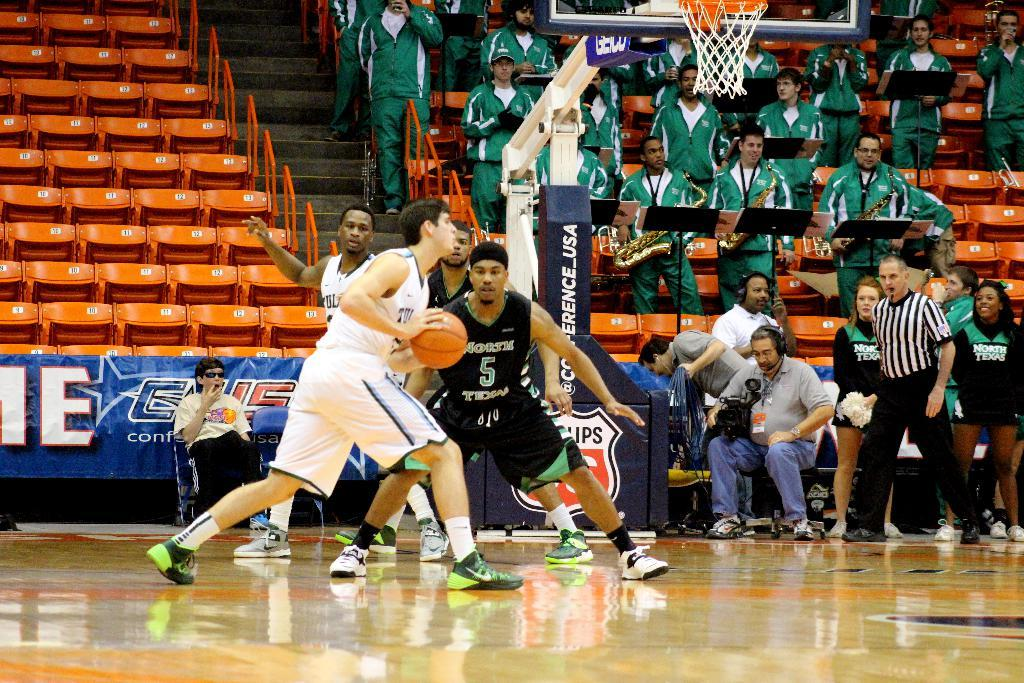<image>
Create a compact narrative representing the image presented. Basketball players in front of a hoop with the Conference USA logo on it. 